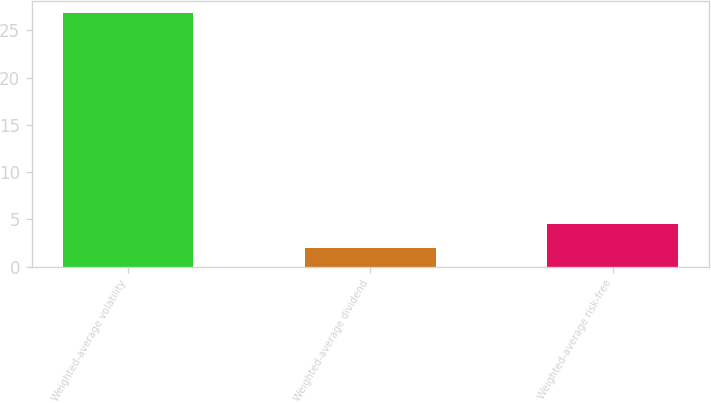<chart> <loc_0><loc_0><loc_500><loc_500><bar_chart><fcel>Weighted-average volatility<fcel>Weighted-average dividend<fcel>Weighted-average risk-free<nl><fcel>26.82<fcel>2<fcel>4.48<nl></chart> 